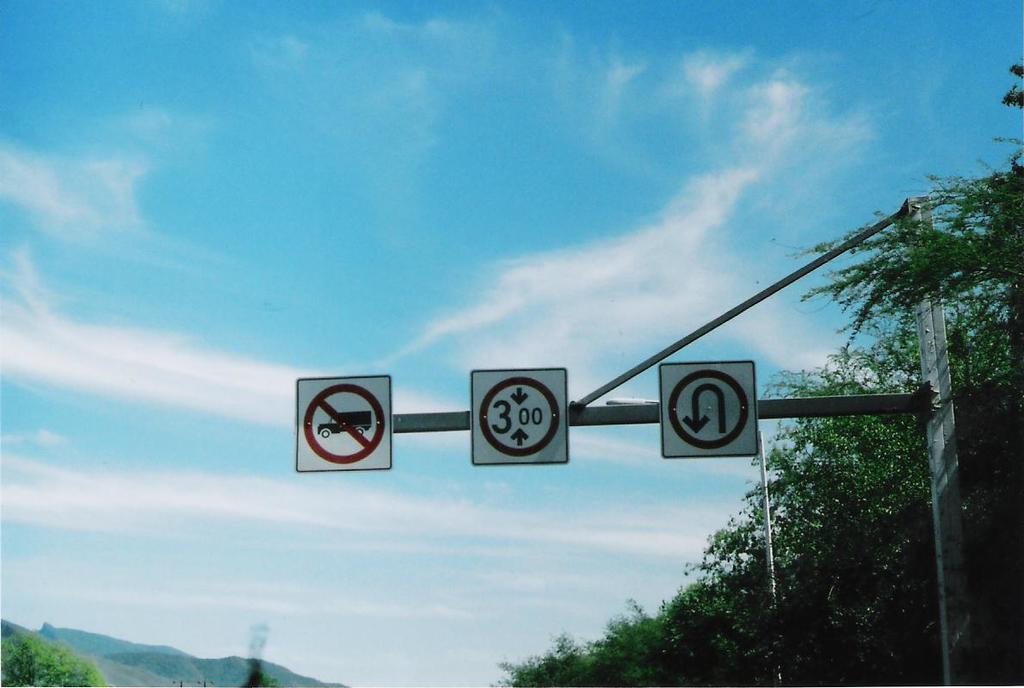<image>
Offer a succinct explanation of the picture presented. the number 3 that is on a sign outside 